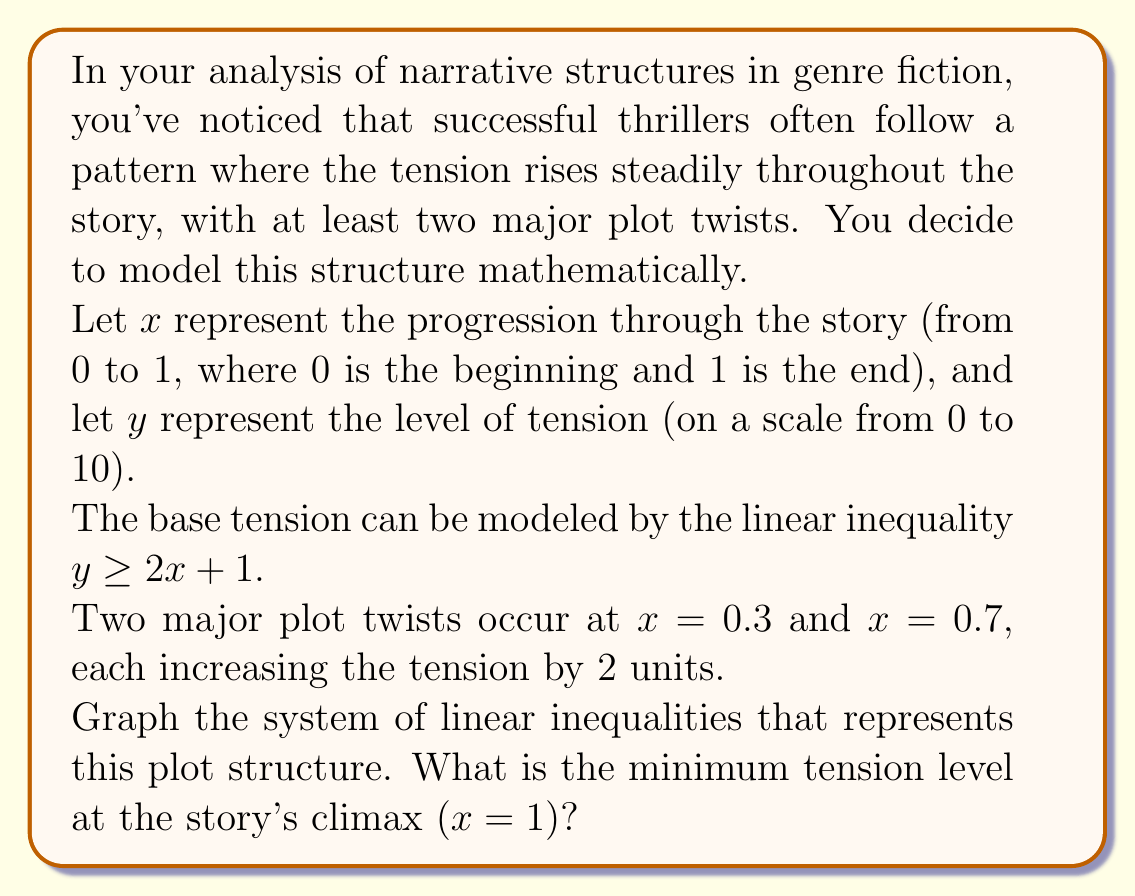Can you solve this math problem? To solve this problem, we need to construct and graph a system of linear inequalities:

1. Start with the base tension line: $y \geq 2x + 1$

2. At $x = 0.3$, the tension increases by 2 units. This creates a new inequality for $x \geq 0.3$:
   $y \geq 2x + 1 + 2 = 2x + 3$

3. At $x = 0.7$, the tension increases by another 2 units. This creates a final inequality for $x \geq 0.7$:
   $y \geq 2x + 1 + 2 + 2 = 2x + 5$

Our system of inequalities is:
$$
\begin{cases}
y \geq 2x + 1 & \text{for } 0 \leq x < 0.3 \\
y \geq 2x + 3 & \text{for } 0.3 \leq x < 0.7 \\
y \geq 2x + 5 & \text{for } 0.7 \leq x \leq 1
\end{cases}
$$

To find the minimum tension at the story's climax, we evaluate the last inequality at $x = 1$:

$y \geq 2(1) + 5 = 7$

Therefore, the minimum tension level at the story's climax ($x = 1$) is 7.

Here's a graph of the system of inequalities:

[asy]
import graph;
size(200,200);

xaxis("x",0,1,Arrow);
yaxis("y",0,10,Arrow);

draw((0,1)--(0.3,1.6),blue);
draw((0.3,3.6)--(0.7,4.4),blue);
draw((0.7,6.4)--(1,7),blue);

fill((0,1)--(0.3,1.6)--(0.3,10)--(0,10)--cycle,blue+opacity(0.1));
fill((0.3,3.6)--(0.7,4.4)--(0.7,10)--(0.3,10)--cycle,blue+opacity(0.1));
fill((0.7,6.4)--(1,7)--(1,10)--(0.7,10)--cycle,blue+opacity(0.1));

label("$y \geq 2x + 1$", (0.15,1.3), E);
label("$y \geq 2x + 3$", (0.5,4), E);
label("$y \geq 2x + 5$", (0.85,6.7), E);

dot((0.3,3.6),red);
dot((0.7,6.4),red);
dot((1,7),red);

label("(0.3, 3.6)", (0.3,3.6), SW);
label("(0.7, 6.4)", (0.7,6.4), SW);
label("(1, 7)", (1,7), SE);
[/asy]
Answer: The minimum tension level at the story's climax (x = 1) is 7. 